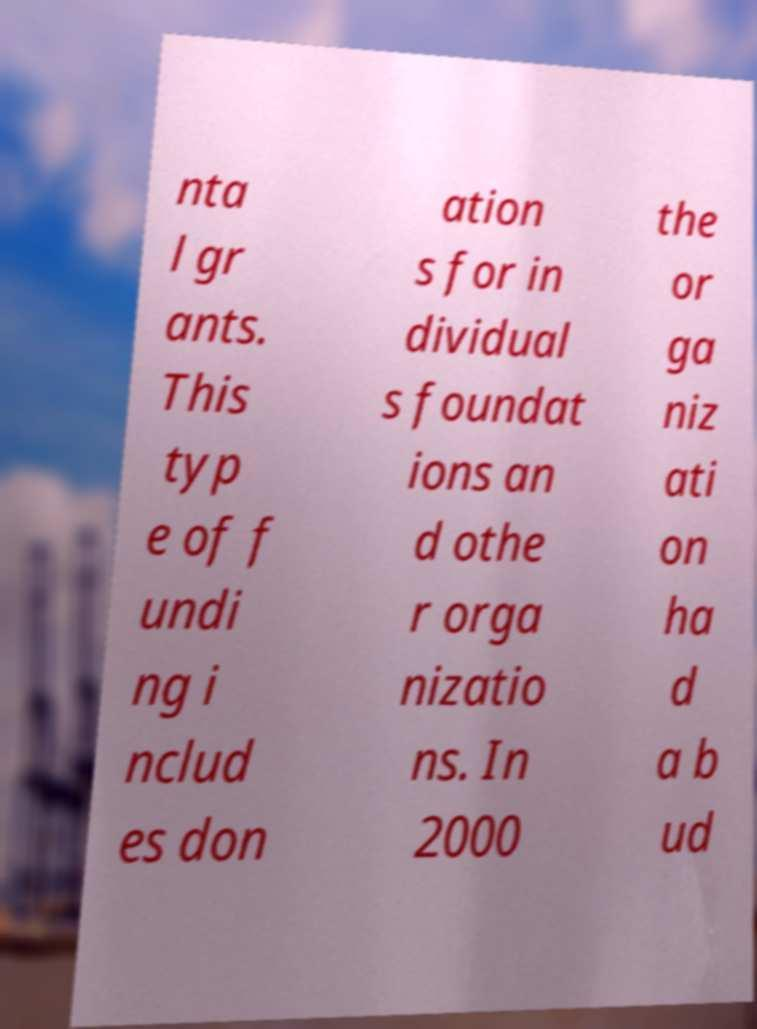Could you assist in decoding the text presented in this image and type it out clearly? nta l gr ants. This typ e of f undi ng i nclud es don ation s for in dividual s foundat ions an d othe r orga nizatio ns. In 2000 the or ga niz ati on ha d a b ud 